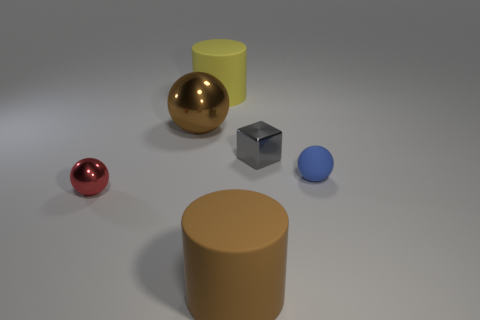Subtract all tiny spheres. How many spheres are left? 1 Subtract all brown spheres. How many spheres are left? 2 Subtract 1 cylinders. How many cylinders are left? 1 Subtract all cyan blocks. How many gray balls are left? 0 Add 4 small matte spheres. How many objects exist? 10 Subtract all cylinders. How many objects are left? 4 Add 6 matte balls. How many matte balls exist? 7 Subtract 0 green cylinders. How many objects are left? 6 Subtract all brown cylinders. Subtract all purple cubes. How many cylinders are left? 1 Subtract all big balls. Subtract all small red metallic objects. How many objects are left? 4 